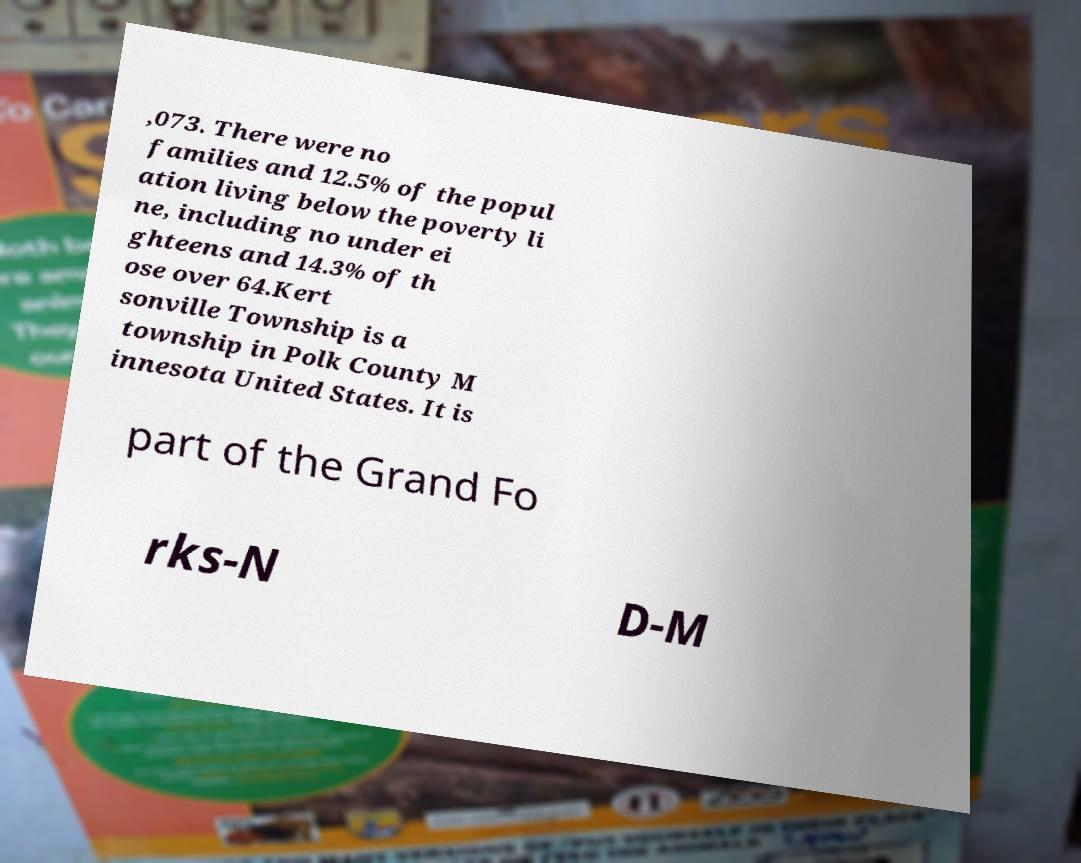There's text embedded in this image that I need extracted. Can you transcribe it verbatim? ,073. There were no families and 12.5% of the popul ation living below the poverty li ne, including no under ei ghteens and 14.3% of th ose over 64.Kert sonville Township is a township in Polk County M innesota United States. It is part of the Grand Fo rks-N D-M 